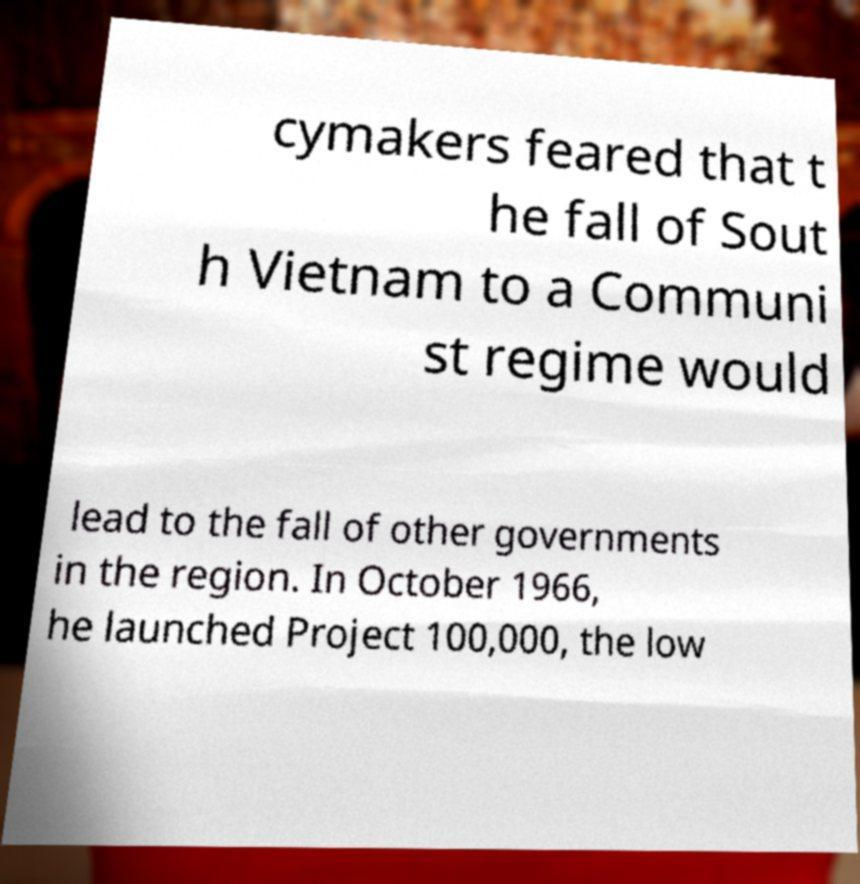What messages or text are displayed in this image? I need them in a readable, typed format. cymakers feared that t he fall of Sout h Vietnam to a Communi st regime would lead to the fall of other governments in the region. In October 1966, he launched Project 100,000, the low 